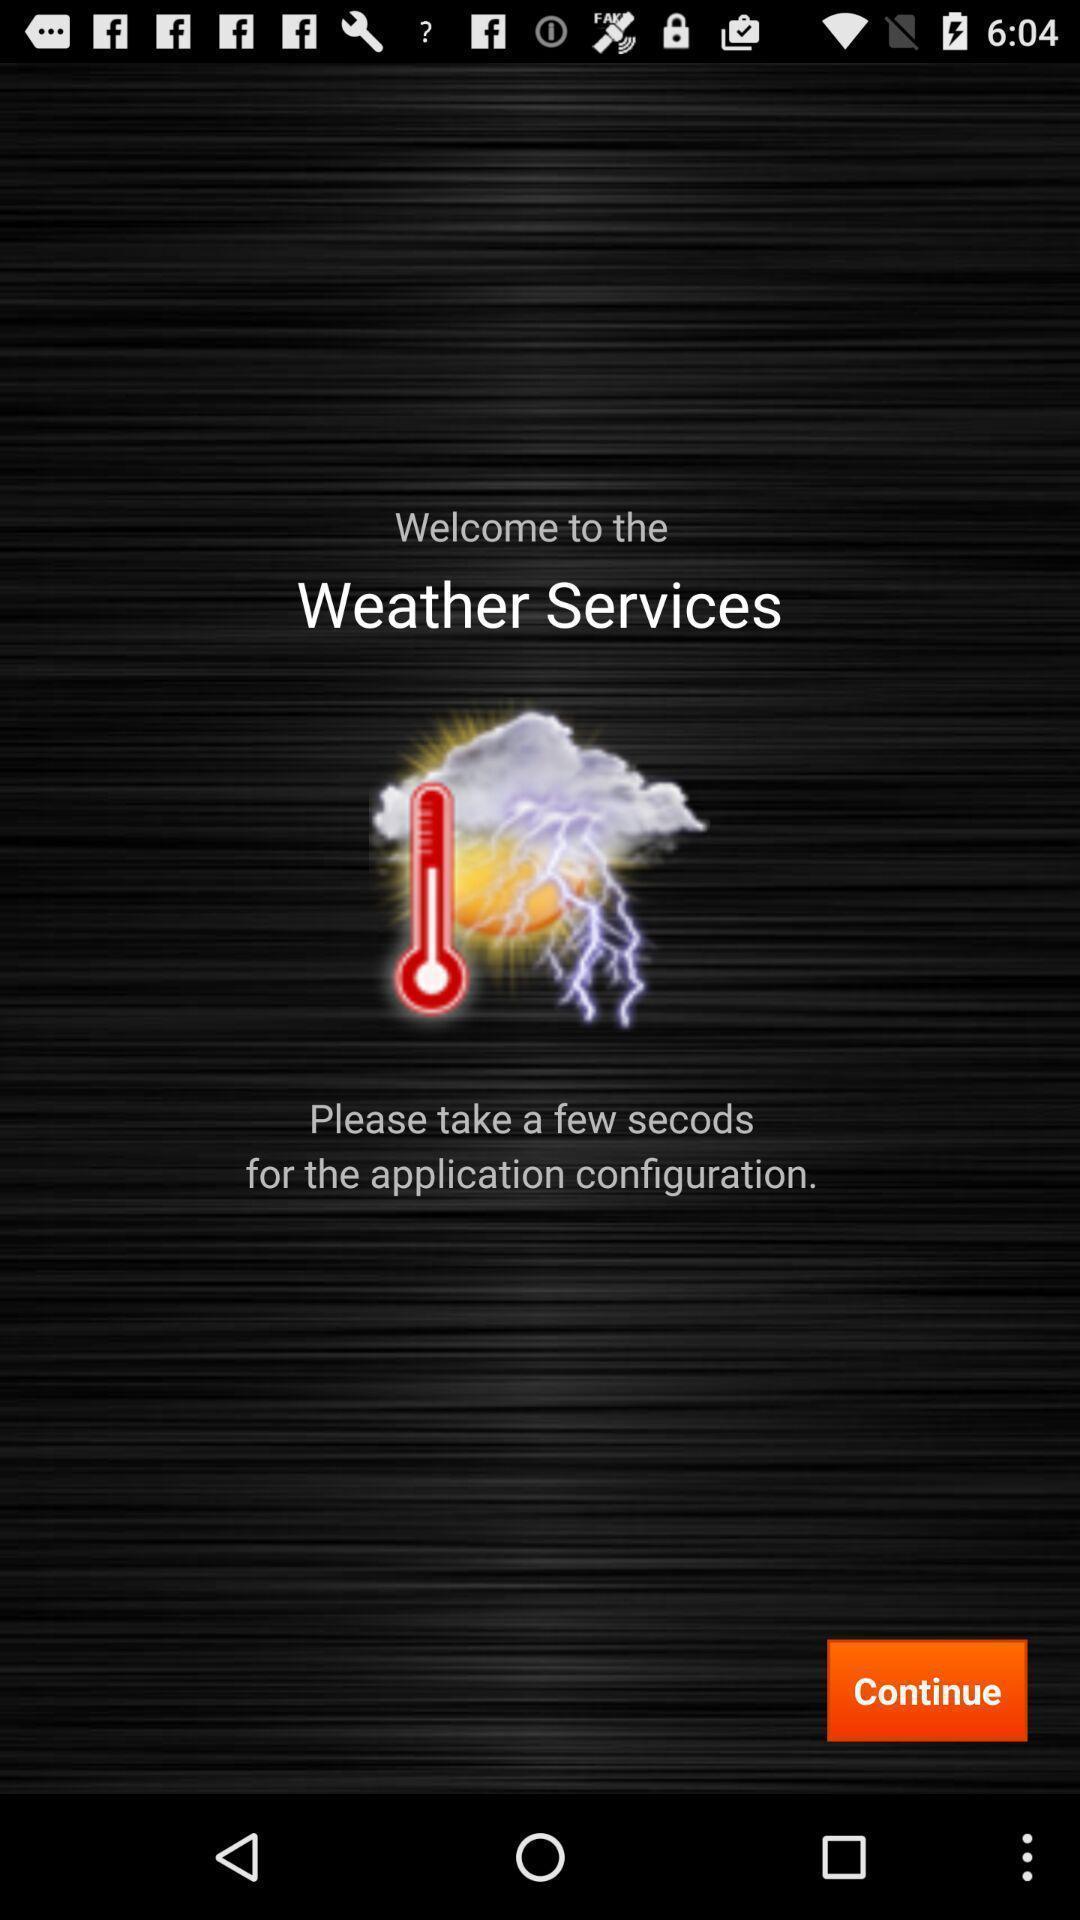Provide a detailed account of this screenshot. Welcome page for weather forecasting app. 